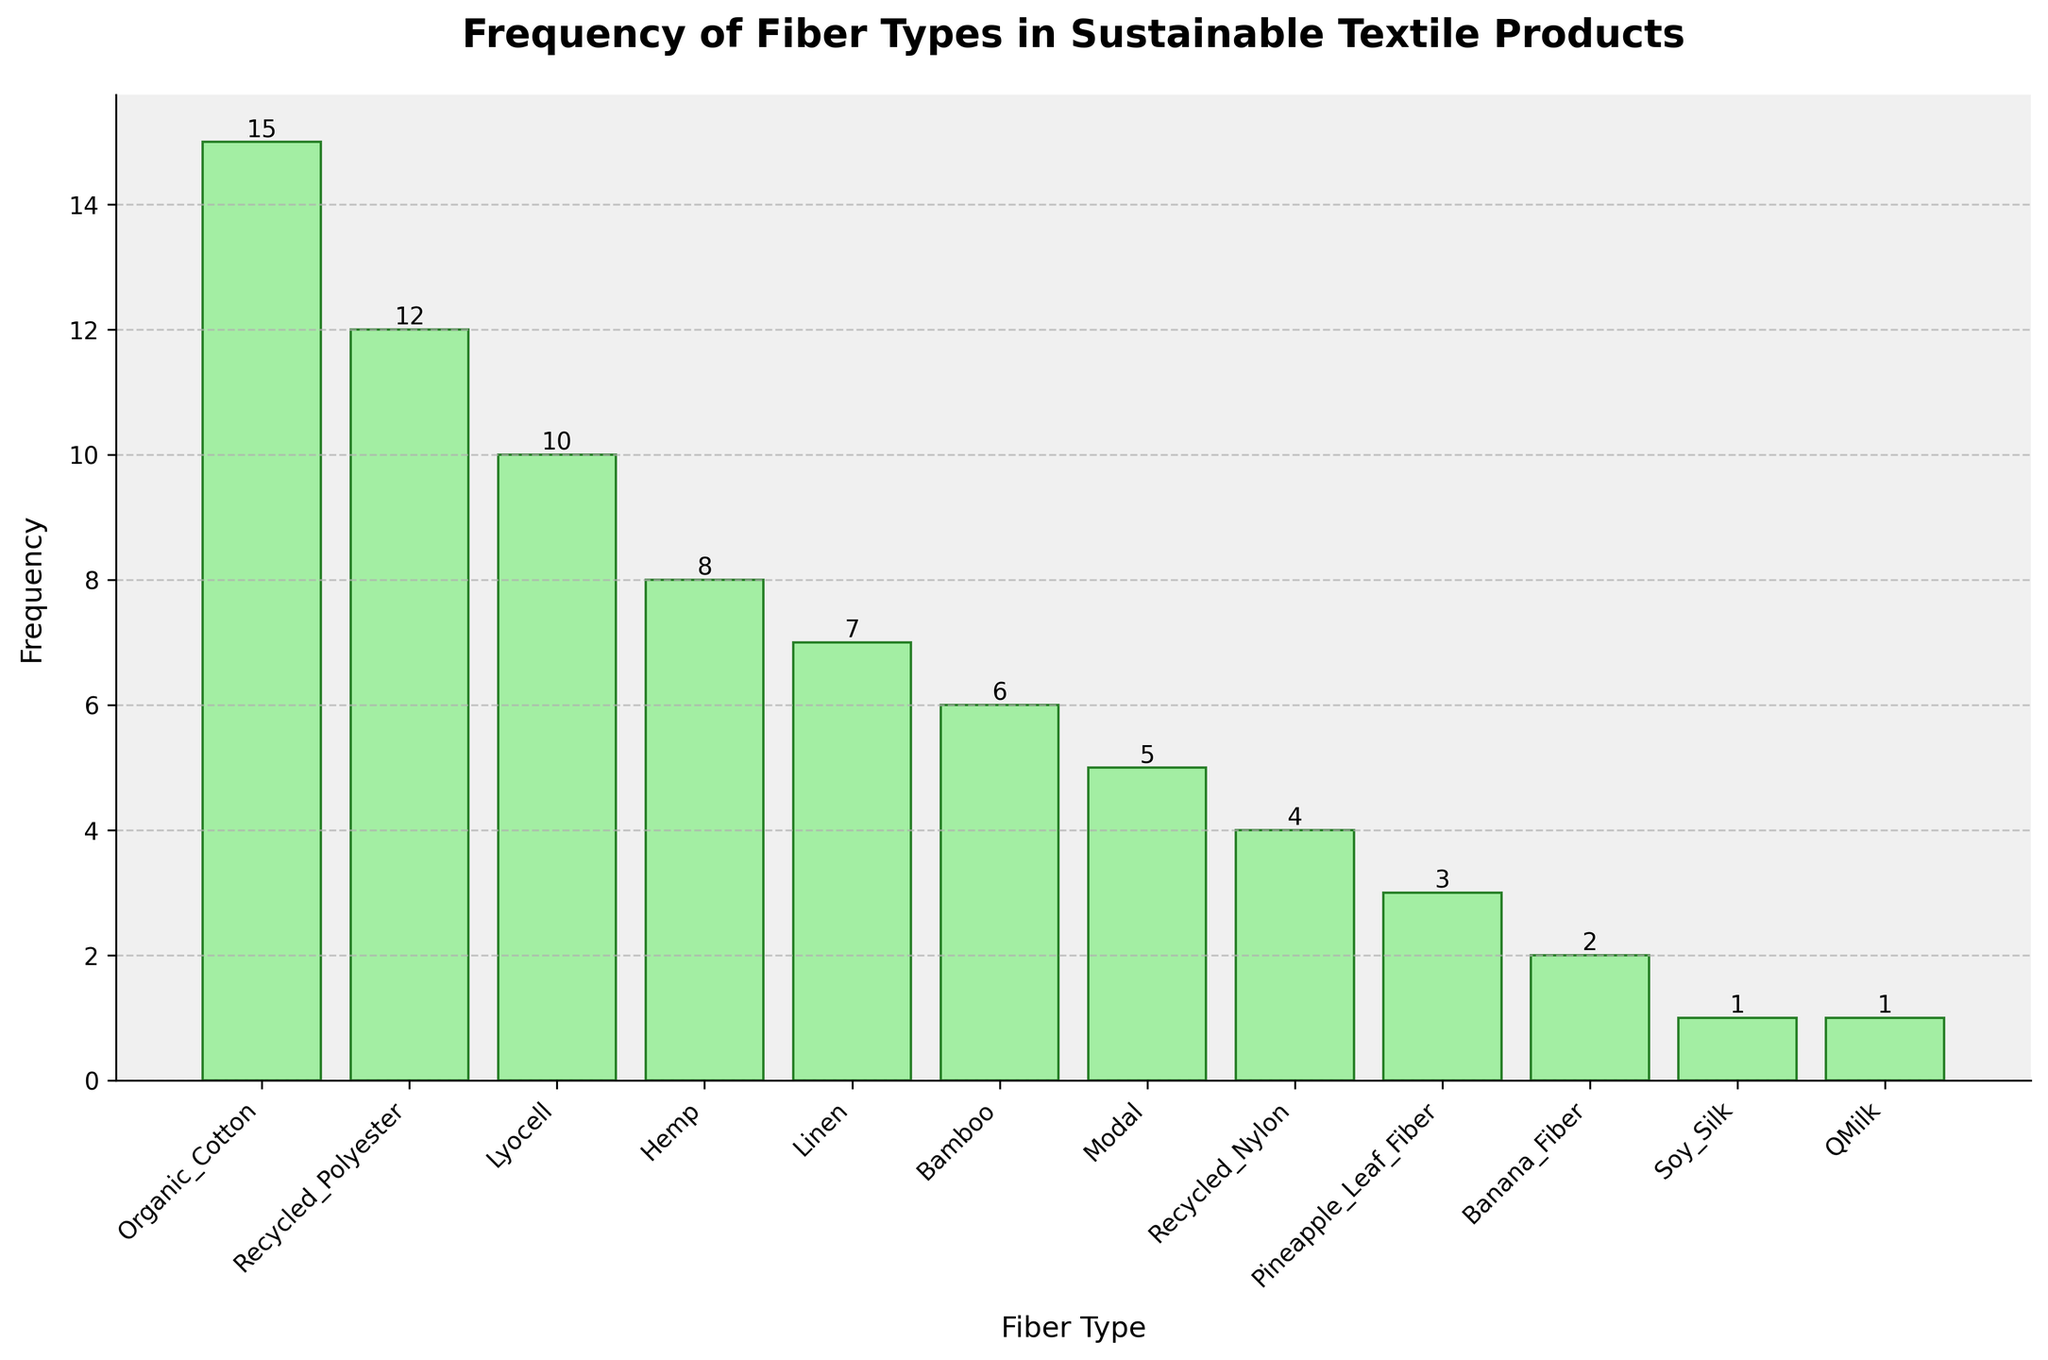What is the title of the figure? The title is displayed at the top center of the plot. It reads "Frequency of Fiber Types in Sustainable Textile Products".
Answer: Frequency of Fiber Types in Sustainable Textile Products How many different fiber types are shown in the figure? Count the number of distinct bars on the x-axis, each representing a different fiber type. There are 12 different fiber types.
Answer: 12 Which fiber type is used most frequently in sustainable textile products according to the figure? Identify the tallest bar on the x-axis. The fiber type with the highest bar is "Organic Cotton".
Answer: Organic Cotton What is the frequency of "Bamboo" fiber type in the figure? Look for the bar labeled "Bamboo" on the x-axis and note the height of the bar, which corresponds to the frequency value. The frequency is 6.
Answer: 6 What is the frequency difference between "Organic Cotton" and "Linen"? Find the bars labeled "Organic Cotton" and "Linen". The heights are 15 and 7, respectively. The difference is calculated as 15 - 7 = 8.
Answer: 8 Which fiber types have the same frequency in the figure? Identify bars of equal height. Both "Soy Silk" and "QMilk" have heights of 1, meaning they have the same frequency.
Answer: Soy Silk and QMilk What is the average frequency of all fiber types in the figure? Sum the frequencies of all fiber types and divide by the total number of fiber types. The sum is 15 + 12 + 8 + 10 + 6 + 5 + 4 + 7 + 3 + 2 + 1 + 1 = 74. Dividing by 12 gives 74 / 12 ≈ 6.17.
Answer: 6.17 What are the top three most frequently used fiber types in sustainable textile products? Identify the three tallest bars on the x-axis. The top three are "Organic Cotton" (15), "Recycled Polyester" (12), and "Lyocell" (10).
Answer: Organic Cotton, Recycled Polyester, and Lyocell 